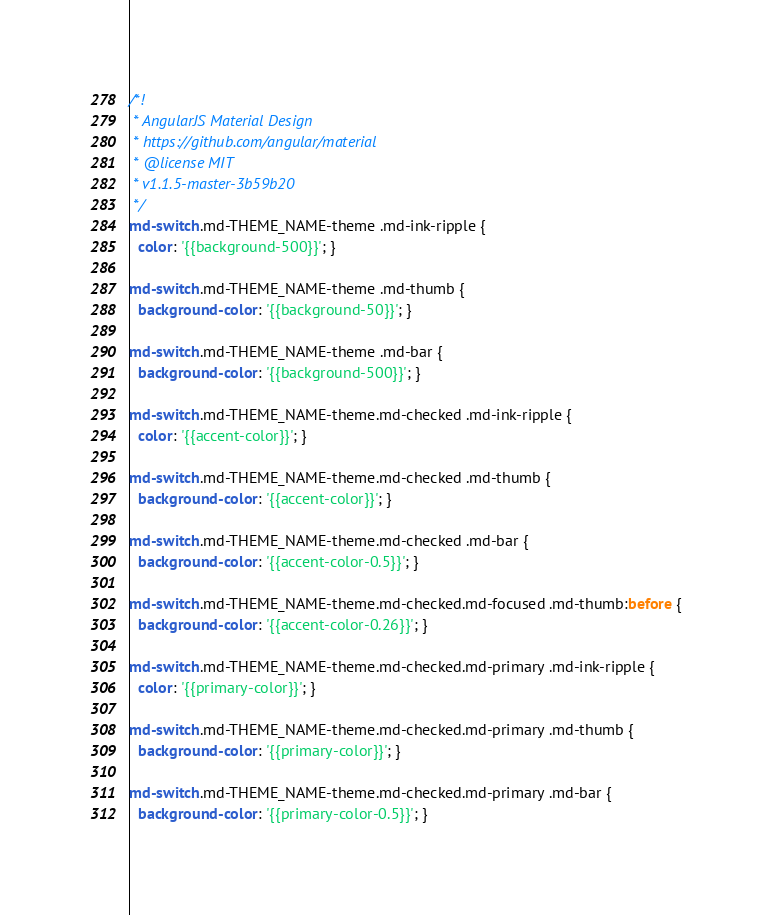Convert code to text. <code><loc_0><loc_0><loc_500><loc_500><_CSS_>/*!
 * AngularJS Material Design
 * https://github.com/angular/material
 * @license MIT
 * v1.1.5-master-3b59b20
 */
md-switch.md-THEME_NAME-theme .md-ink-ripple {
  color: '{{background-500}}'; }

md-switch.md-THEME_NAME-theme .md-thumb {
  background-color: '{{background-50}}'; }

md-switch.md-THEME_NAME-theme .md-bar {
  background-color: '{{background-500}}'; }

md-switch.md-THEME_NAME-theme.md-checked .md-ink-ripple {
  color: '{{accent-color}}'; }

md-switch.md-THEME_NAME-theme.md-checked .md-thumb {
  background-color: '{{accent-color}}'; }

md-switch.md-THEME_NAME-theme.md-checked .md-bar {
  background-color: '{{accent-color-0.5}}'; }

md-switch.md-THEME_NAME-theme.md-checked.md-focused .md-thumb:before {
  background-color: '{{accent-color-0.26}}'; }

md-switch.md-THEME_NAME-theme.md-checked.md-primary .md-ink-ripple {
  color: '{{primary-color}}'; }

md-switch.md-THEME_NAME-theme.md-checked.md-primary .md-thumb {
  background-color: '{{primary-color}}'; }

md-switch.md-THEME_NAME-theme.md-checked.md-primary .md-bar {
  background-color: '{{primary-color-0.5}}'; }
</code> 